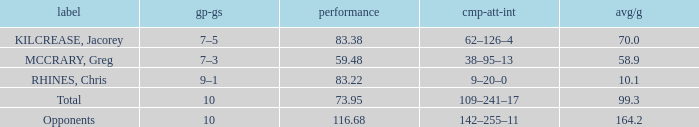What is the total avg/g of McCrary, Greg? 1.0. 